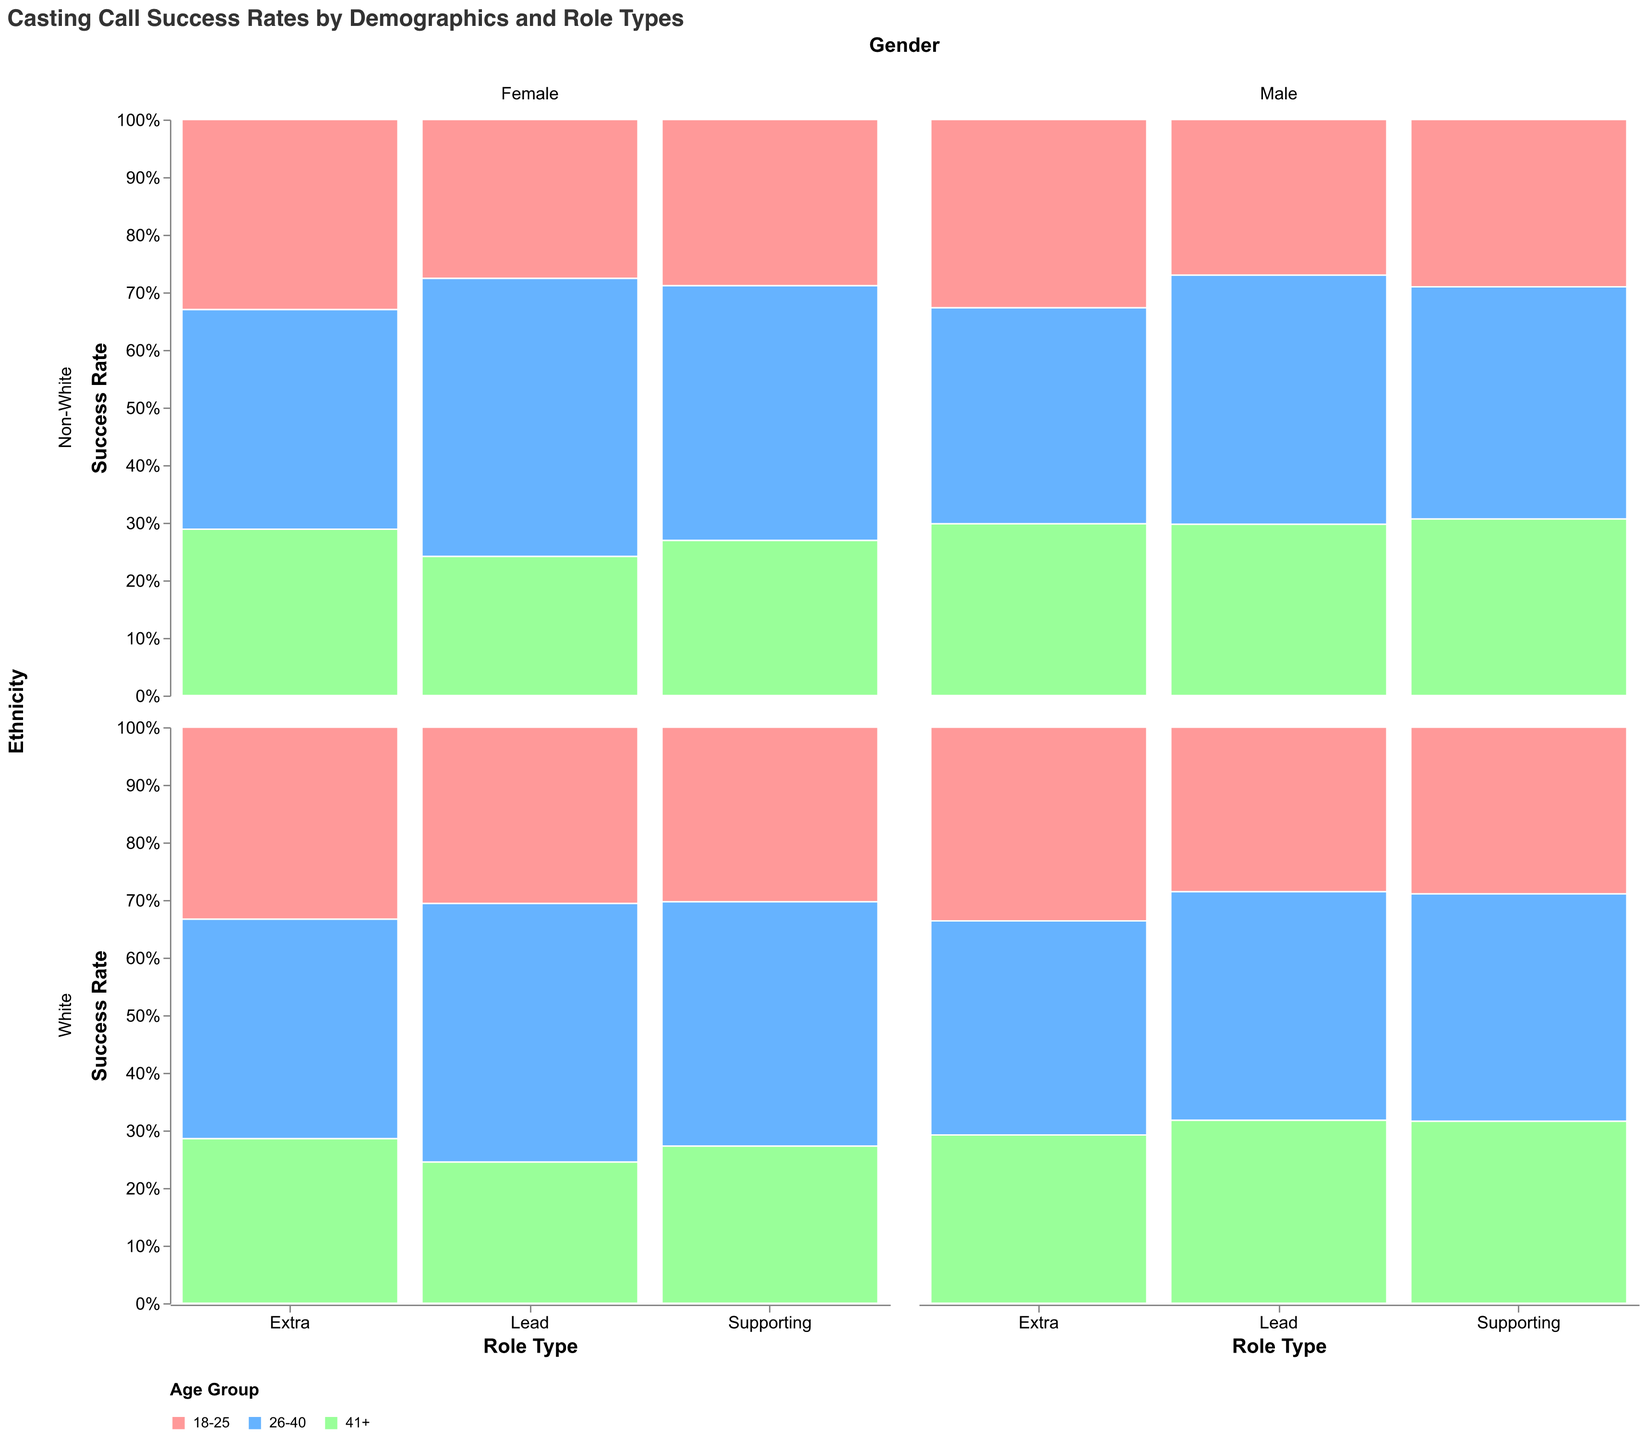What is the color that represents the age group 41+? The legend indicates that different age groups are represented by different colors. The color associated with the age group 41+ is green.
Answer: Green What is the success rate for Non-White females aged 26-40 in lead roles? Find the "Lead" role type, locate "26-40" age group, "Female" gender, and "Non-White" ethnicity; the plot shows their success rate. The success rate can be deduced to be 14.
Answer: 14 Which role type has the highest success rate for White males aged 26-40? Compare the success rates across different role types (Lead, Supporting, Extra) for White males aged 26-40. The highest success rate is for Extra roles.
Answer: Extra What is the overall trend in success rates for supporting roles compared to lead roles? Examine the success rate percentages for each demographic in supporting roles versus lead roles. Supporting roles generally have higher success rates compared to lead roles.
Answer: Supporting roles have higher success rates Do Non-White actors have higher success rates in extra roles compared to other roles? Evaluate the success rates for Non-White actors across different role types. Extra roles have significantly higher success rates compared to lead and supporting roles.
Answer: Yes, they do Which demographic group shows the highest success rate for lead roles? For lead roles, compare the success rates across all demographic groups (Age Group, Gender, Ethnicity). The highest success rate in this category is for White males aged 26-40.
Answer: White males aged 26-40 How do the success rates for females aged 41+ compare between supporting and extra roles? Compare the success rates for females aged 41+ in supporting roles and extra roles. The success rate is higher for extra roles at 30% versus supporting roles at 18%.
Answer: Extra roles have higher success rates What percentage success rate do Non-White males aged 18-25 have for supporting roles? Look at the section for Non-White males aged 18-25 in supporting roles; the plot shows their success rate as 18. To convert to percentage, it's 18%.
Answer: 18% Are there any demographic groups with decreasing success rates as age progresses? Examine the success rates across age groups (18-25, 26-40, 41+) for consistency in decreasing trend. For instance, for Non-White females in lead roles, the rates decrease from 18-25 to 41+ (8, 14, 7).
Answer: Yes Is there a noticeable gender difference in success rates for the 26-40 age group across all role types? Compare the success rates for males and females within the 26-40 age group across Lead, Supporting, and Extra roles. Generally, males tend to have higher success rates compared to females in this age group across all role types.
Answer: Males generally have higher success rates 